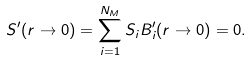Convert formula to latex. <formula><loc_0><loc_0><loc_500><loc_500>S ^ { \prime } ( r \rightarrow 0 ) = \sum _ { i = 1 } ^ { N _ { M } } S _ { i } B _ { i } ^ { \prime } ( r \rightarrow 0 ) = 0 .</formula> 